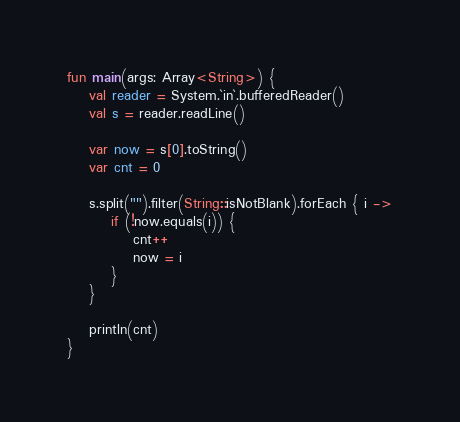Convert code to text. <code><loc_0><loc_0><loc_500><loc_500><_Kotlin_>fun main(args: Array<String>) {
    val reader = System.`in`.bufferedReader()
    val s = reader.readLine()

    var now = s[0].toString()
    var cnt = 0

    s.split("").filter(String::isNotBlank).forEach { i ->
        if (!now.equals(i)) {
            cnt++
            now = i
        }
    }

    println(cnt)
}
</code> 